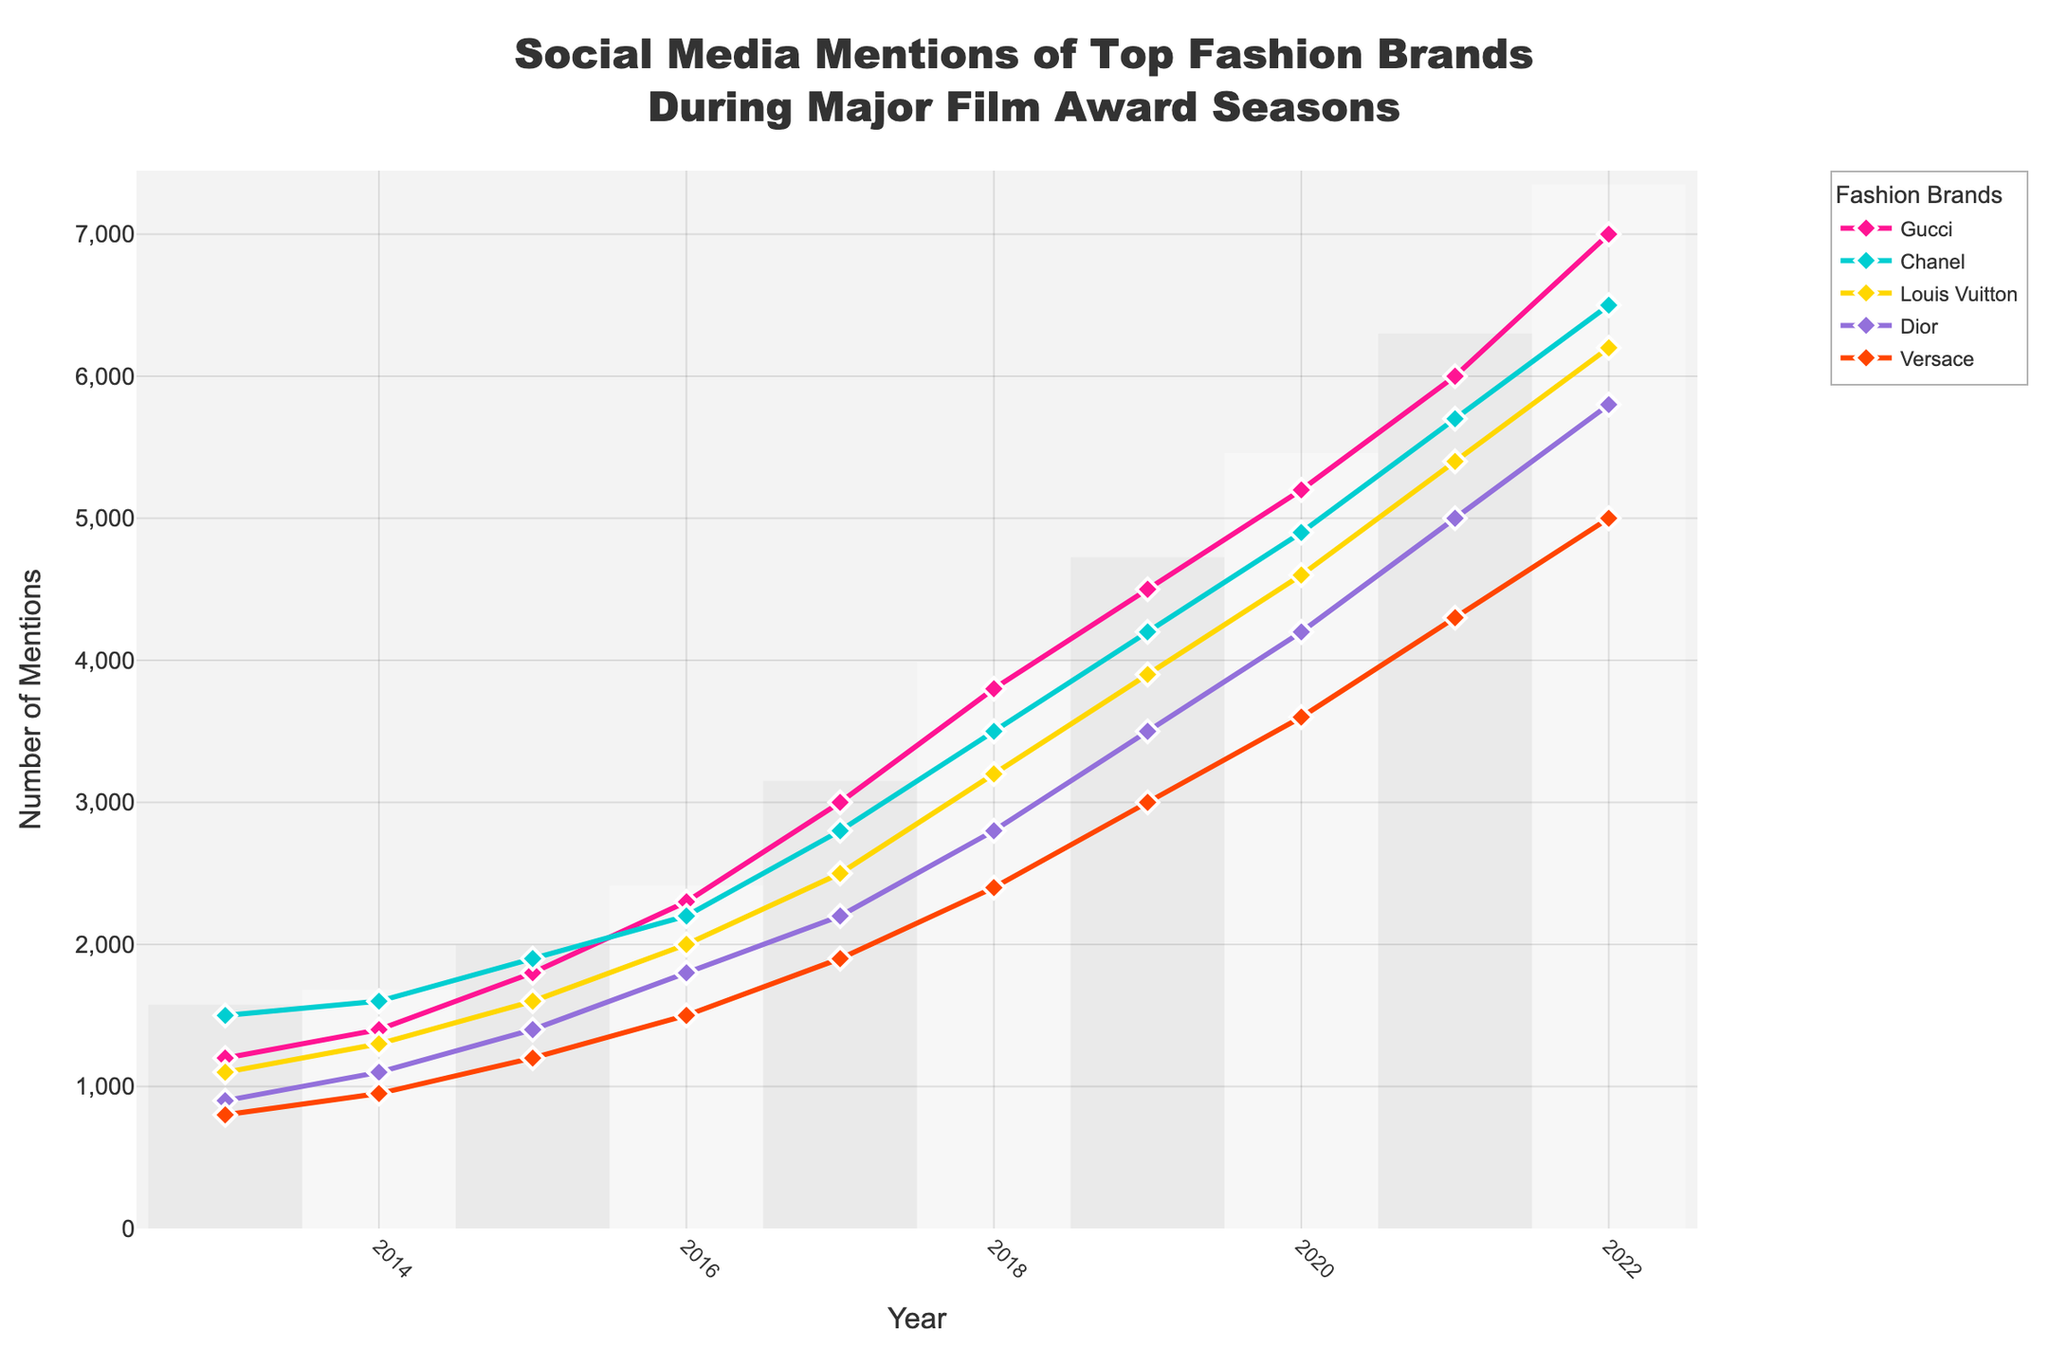What's the increasing trend in mentions for Gucci from 2013 to 2022? Starting from 1200 mentions in 2013, Gucci's mentions increase year by year to 7000 in 2022, showing a consistent upward trend.
Answer: Consistently upward from 1200 to 7000 Which brand had the highest number of mentions in 2019? Verify the number of mentions for each brand in 2019 and find that Gucci had the highest at 4500.
Answer: Gucci Between 2014 and 2016, which brand saw the largest absolute increase in mentions? Calculate the difference in mentions between 2014 and 2016: 
Gucci (2300-1400 = 900), 
Chanel (2200-1600 = 600), 
Louis Vuitton (2000-1300 = 700), 
Dior (1800-1100 = 700), 
Versace (1500-950 = 550). Gucci saw the largest increase of 900 mentions.
Answer: Gucci By comparing the slope of the lines, which brand had the most rapid increase in mentions between 2018 and 2020? Calculate the difference in mentions from 2018 to 2020 for each brand, divided by 2 years: 
Gucci (5200-3800 = 1400/2 = 700), 
Chanel (4900-3500 = 1400/2 = 700), 
Louis Vuitton (4600-3200 = 1400/2 = 700), 
Dior (4200-2800 = 1400/2 = 700), 
Versace (3600-2400 = 1200/2 = 600). All brands except Versace increased equally rapidly at 700 mentions/year.
Answer: Gucci, Chanel, Louis Vuitton, Dior Which brand's mentions remained closest to Dior's in 2021? Compare the mentions in 2021 for Dior (5000) with other brands: 
Gucci (6000), 
Chanel (5700), 
Louis Vuitton (5400), 
Versace (4300). Louis Vuitton's 5400 is closest to Dior's 5000.
Answer: Louis Vuitton What is the sum of mentions for all brands in 2017? Add the mentions for all brands in 2017: 
Gucci (3000) + Chanel (2800) + Louis Vuitton (2500) + Dior (2200) + Versace (1900) = 12400.
Answer: 12400 During which year did Versace have the smallest increase compared to the previous year? Calculate annual changes for Versace:
2014 (950-800=150), 
2015 (1200-950=250), 
2016 (1500-1200=300), 
2017 (1900-1500=400), 
2018 (2400-1900=500), 
2019 (3000-2400=600), 
2020 (3600-3000=600), 
2021 (4300-3600=700), 
2022 (5000-4300=700). The smallest increase is 150 in 2014 compared to 2013.
Answer: 2014 What was the average number of mentions for Chanel between 2016 and 2022, inclusive? Calculate the sum and average of Chanel's mentions from 2016 to 2022:
(2200 + 2800 + 3500 + 4200 + 4900 + 5700 + 6500) / 7 = 29800 / 7 = 4257.14.
Answer: 4257.14 Identify the year when Louis Vuitton’s mentions crossed 3000. Look at the annual data for Louis Vuitton:
2018 (3200) is the first year above 3000 mentions.
Answer: 2018 